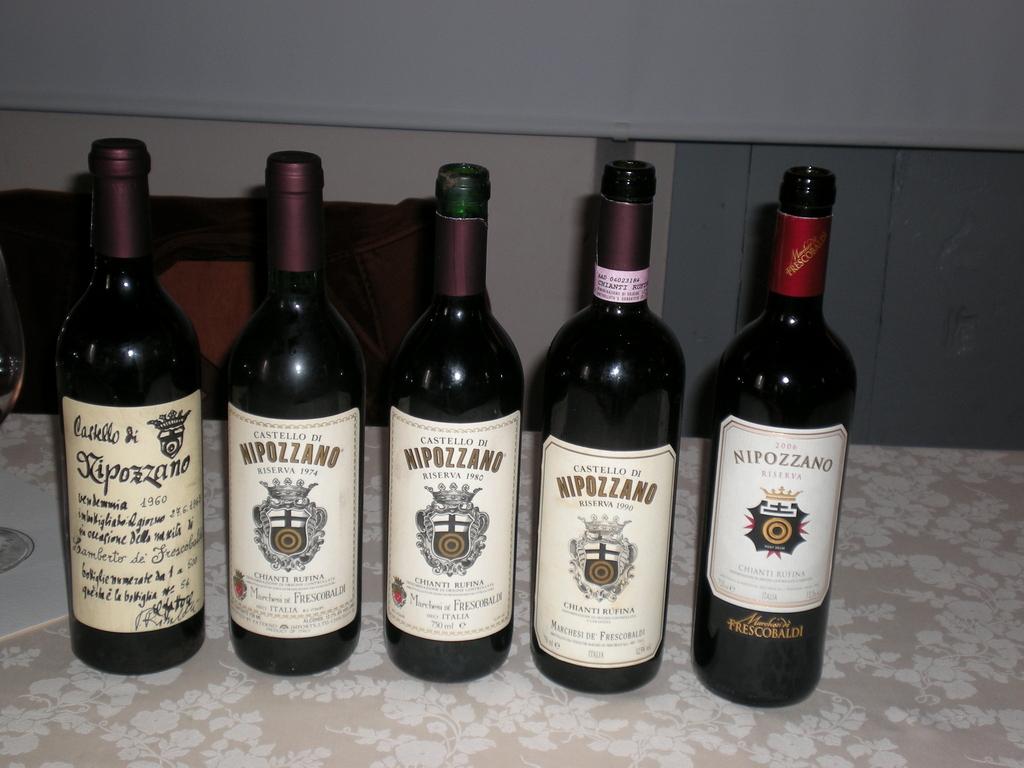What is the year printed in the left corner bottle?
Give a very brief answer. 1960. 